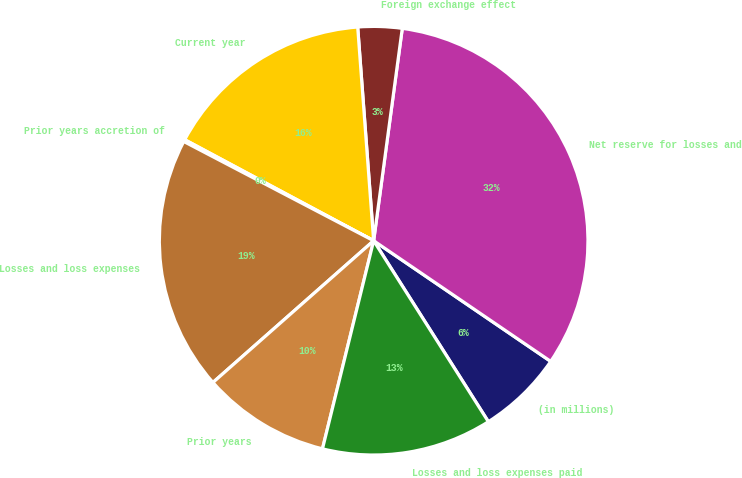<chart> <loc_0><loc_0><loc_500><loc_500><pie_chart><fcel>(in millions)<fcel>Net reserve for losses and<fcel>Foreign exchange effect<fcel>Current year<fcel>Prior years accretion of<fcel>Losses and loss expenses<fcel>Prior years<fcel>Losses and loss expenses paid<nl><fcel>6.49%<fcel>32.39%<fcel>3.32%<fcel>16.0%<fcel>0.15%<fcel>19.17%<fcel>9.66%<fcel>12.83%<nl></chart> 